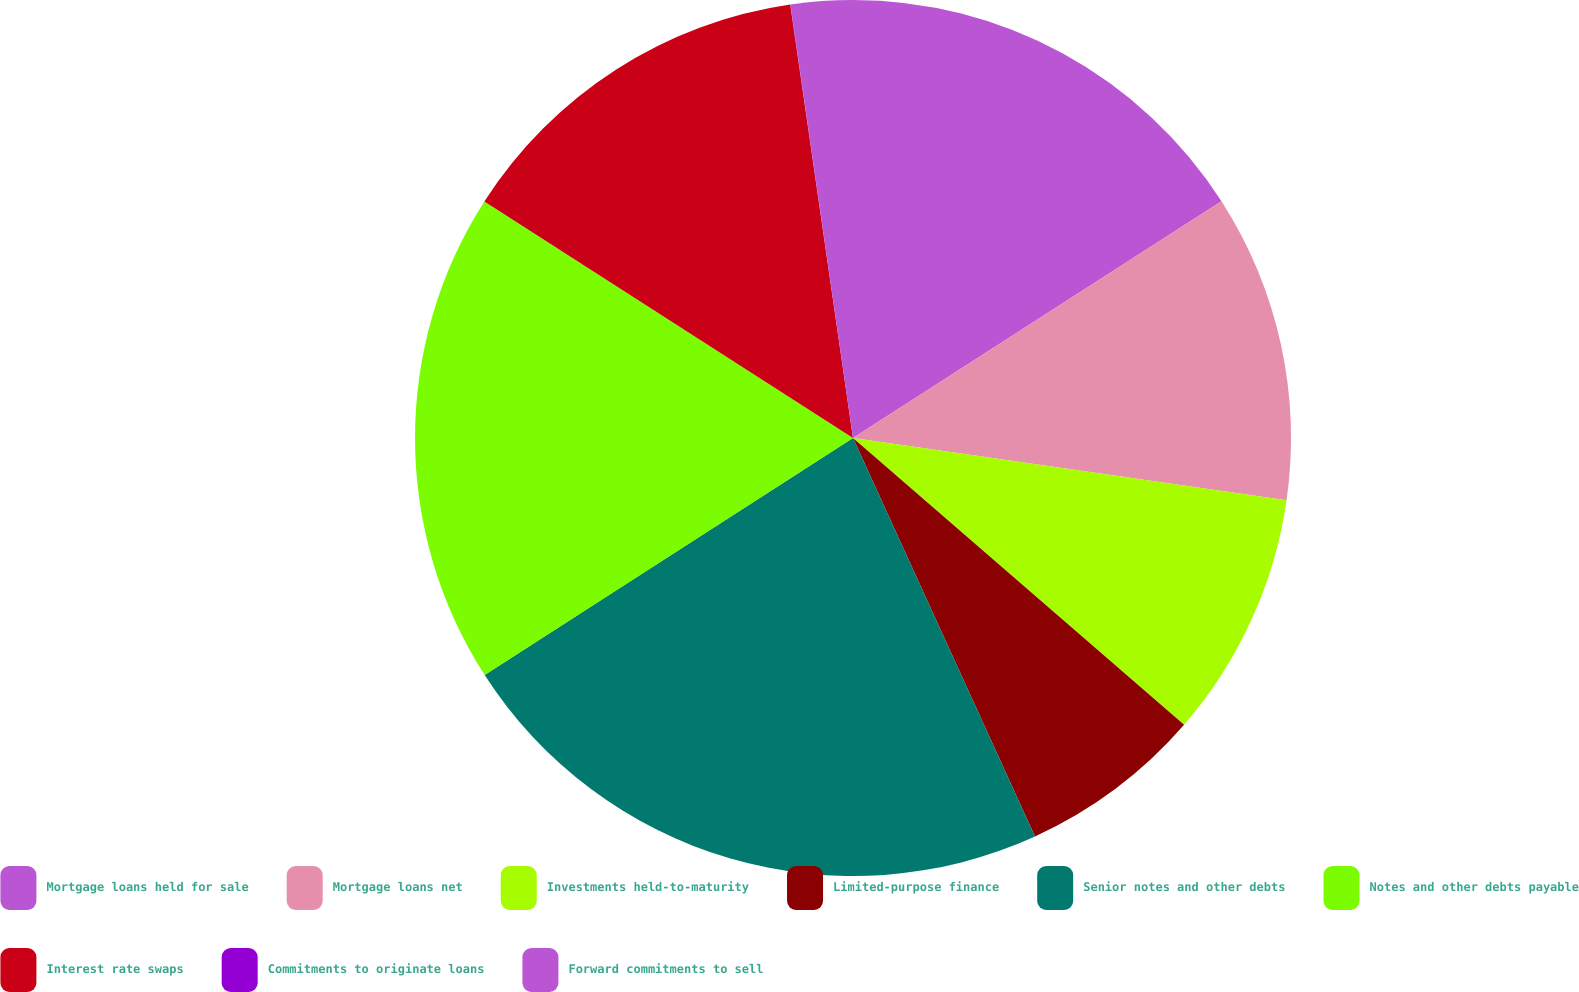Convert chart to OTSL. <chart><loc_0><loc_0><loc_500><loc_500><pie_chart><fcel>Mortgage loans held for sale<fcel>Mortgage loans net<fcel>Investments held-to-maturity<fcel>Limited-purpose finance<fcel>Senior notes and other debts<fcel>Notes and other debts payable<fcel>Interest rate swaps<fcel>Commitments to originate loans<fcel>Forward commitments to sell<nl><fcel>15.91%<fcel>11.36%<fcel>9.09%<fcel>6.82%<fcel>22.72%<fcel>18.18%<fcel>13.63%<fcel>0.01%<fcel>2.28%<nl></chart> 